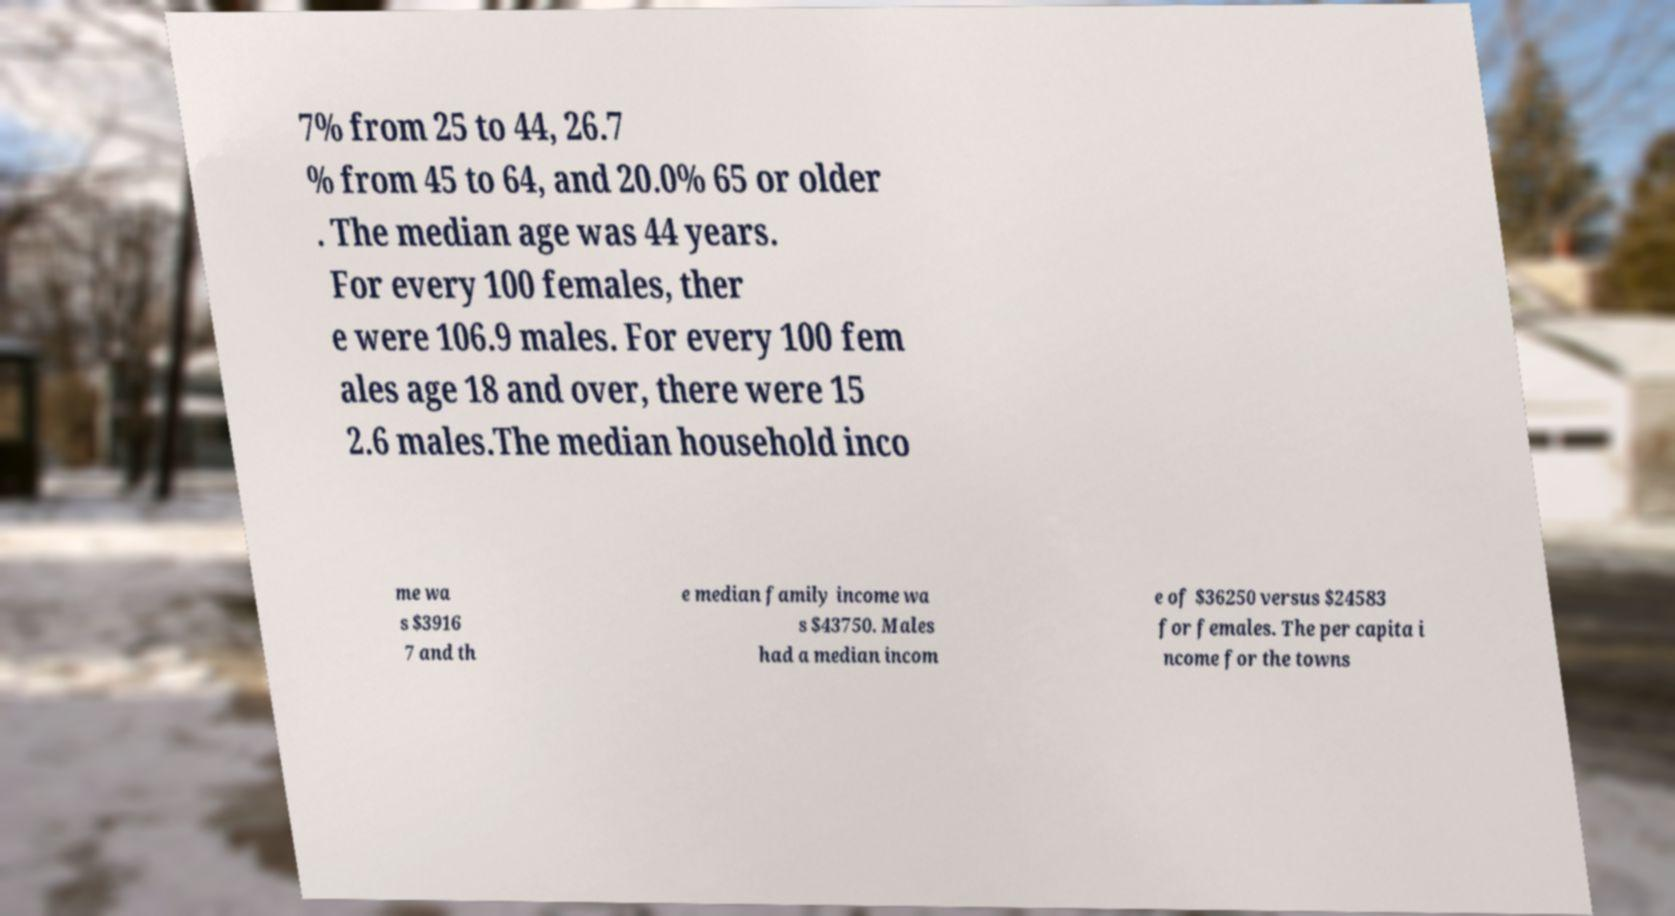Can you accurately transcribe the text from the provided image for me? 7% from 25 to 44, 26.7 % from 45 to 64, and 20.0% 65 or older . The median age was 44 years. For every 100 females, ther e were 106.9 males. For every 100 fem ales age 18 and over, there were 15 2.6 males.The median household inco me wa s $3916 7 and th e median family income wa s $43750. Males had a median incom e of $36250 versus $24583 for females. The per capita i ncome for the towns 